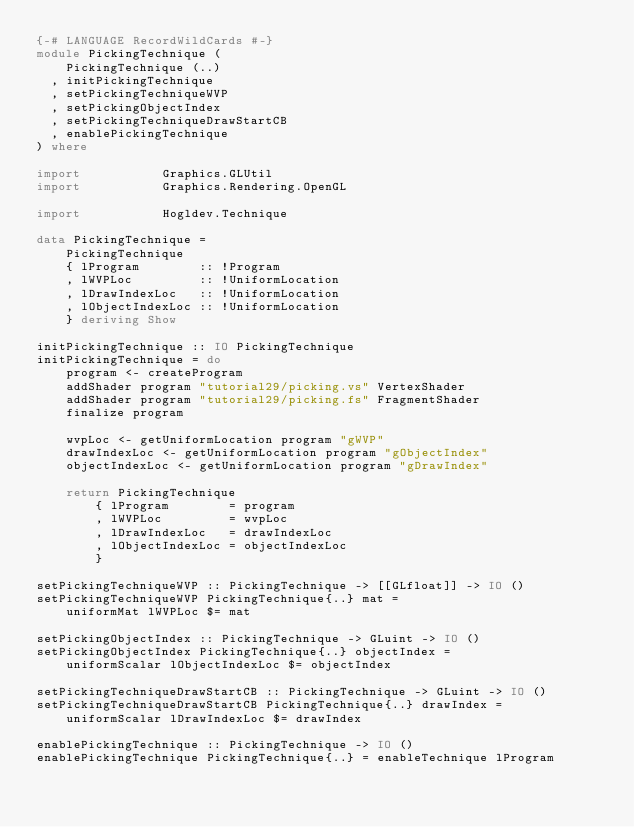<code> <loc_0><loc_0><loc_500><loc_500><_Haskell_>{-# LANGUAGE RecordWildCards #-}
module PickingTechnique (
    PickingTechnique (..)
  , initPickingTechnique
  , setPickingTechniqueWVP
  , setPickingObjectIndex
  , setPickingTechniqueDrawStartCB
  , enablePickingTechnique
) where

import           Graphics.GLUtil
import           Graphics.Rendering.OpenGL

import           Hogldev.Technique

data PickingTechnique =
    PickingTechnique
    { lProgram        :: !Program
    , lWVPLoc         :: !UniformLocation
    , lDrawIndexLoc   :: !UniformLocation
    , lObjectIndexLoc :: !UniformLocation
    } deriving Show

initPickingTechnique :: IO PickingTechnique
initPickingTechnique = do
    program <- createProgram
    addShader program "tutorial29/picking.vs" VertexShader
    addShader program "tutorial29/picking.fs" FragmentShader
    finalize program

    wvpLoc <- getUniformLocation program "gWVP"
    drawIndexLoc <- getUniformLocation program "gObjectIndex"
    objectIndexLoc <- getUniformLocation program "gDrawIndex"

    return PickingTechnique
        { lProgram        = program
        , lWVPLoc         = wvpLoc
        , lDrawIndexLoc   = drawIndexLoc
        , lObjectIndexLoc = objectIndexLoc
        }

setPickingTechniqueWVP :: PickingTechnique -> [[GLfloat]] -> IO ()
setPickingTechniqueWVP PickingTechnique{..} mat =
    uniformMat lWVPLoc $= mat

setPickingObjectIndex :: PickingTechnique -> GLuint -> IO ()
setPickingObjectIndex PickingTechnique{..} objectIndex =
    uniformScalar lObjectIndexLoc $= objectIndex

setPickingTechniqueDrawStartCB :: PickingTechnique -> GLuint -> IO ()
setPickingTechniqueDrawStartCB PickingTechnique{..} drawIndex =
    uniformScalar lDrawIndexLoc $= drawIndex

enablePickingTechnique :: PickingTechnique -> IO ()
enablePickingTechnique PickingTechnique{..} = enableTechnique lProgram
</code> 